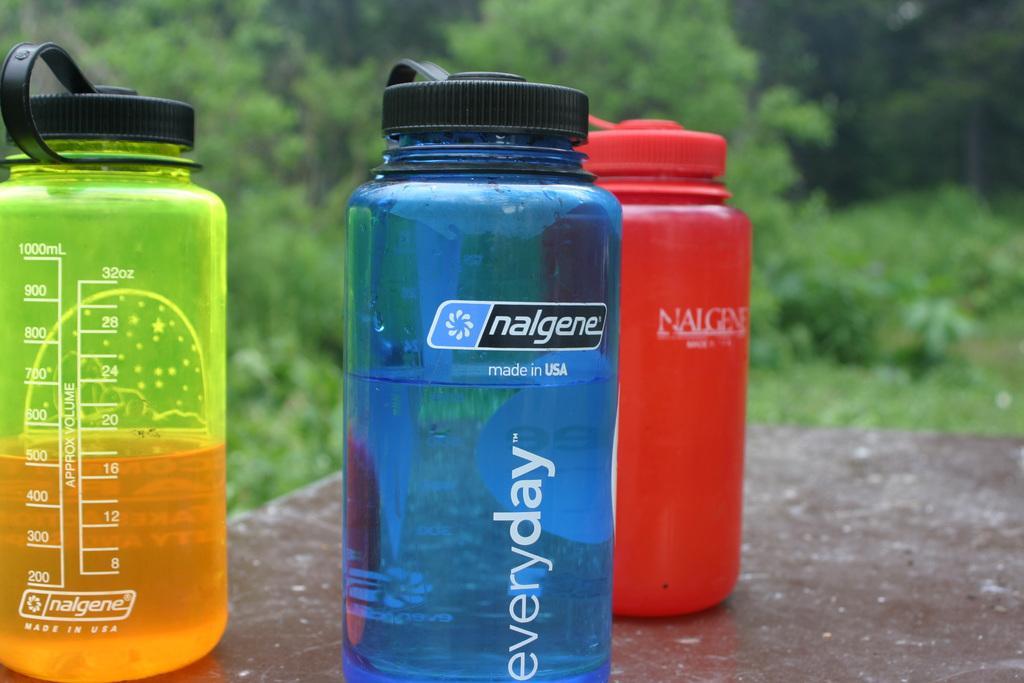Please provide a concise description of this image. In this picture we can see three colors of bottles such as green, blue, red and this are placed on a floor and in the background we can see trees. 